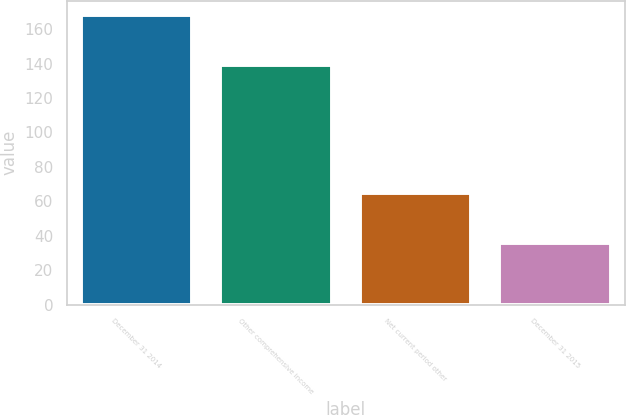Convert chart to OTSL. <chart><loc_0><loc_0><loc_500><loc_500><bar_chart><fcel>December 31 2014<fcel>Other comprehensive income<fcel>Net current period other<fcel>December 31 2015<nl><fcel>168<fcel>139<fcel>65<fcel>36<nl></chart> 